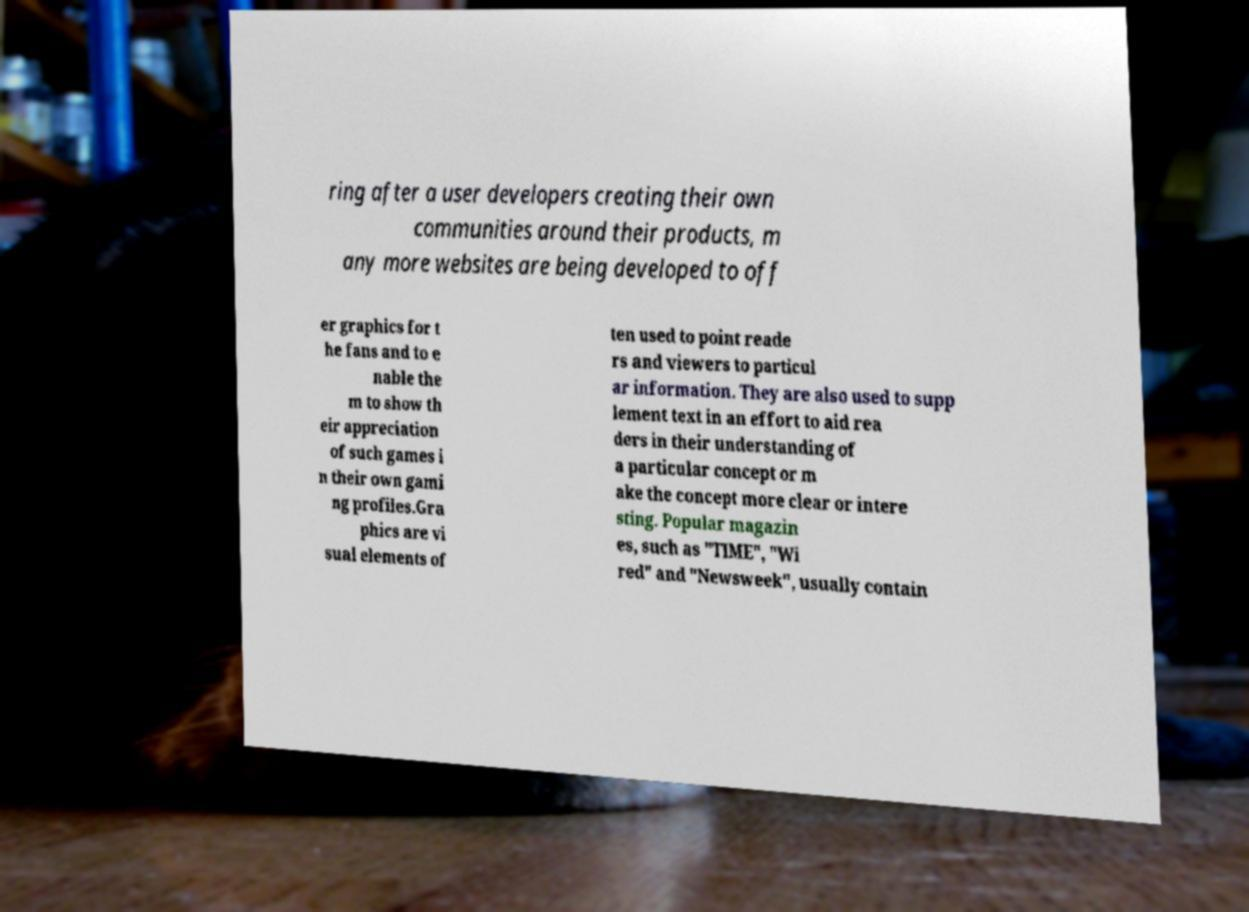For documentation purposes, I need the text within this image transcribed. Could you provide that? ring after a user developers creating their own communities around their products, m any more websites are being developed to off er graphics for t he fans and to e nable the m to show th eir appreciation of such games i n their own gami ng profiles.Gra phics are vi sual elements of ten used to point reade rs and viewers to particul ar information. They are also used to supp lement text in an effort to aid rea ders in their understanding of a particular concept or m ake the concept more clear or intere sting. Popular magazin es, such as "TIME", "Wi red" and "Newsweek", usually contain 